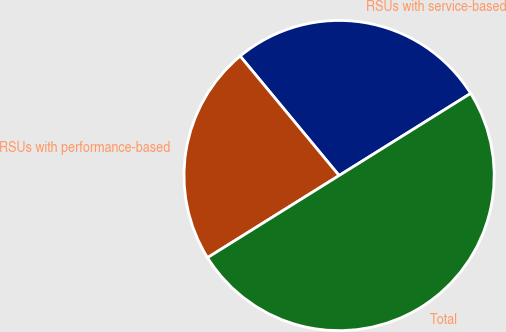Convert chart. <chart><loc_0><loc_0><loc_500><loc_500><pie_chart><fcel>RSUs with service-based<fcel>RSUs with performance-based<fcel>Total<nl><fcel>27.13%<fcel>22.87%<fcel>50.0%<nl></chart> 